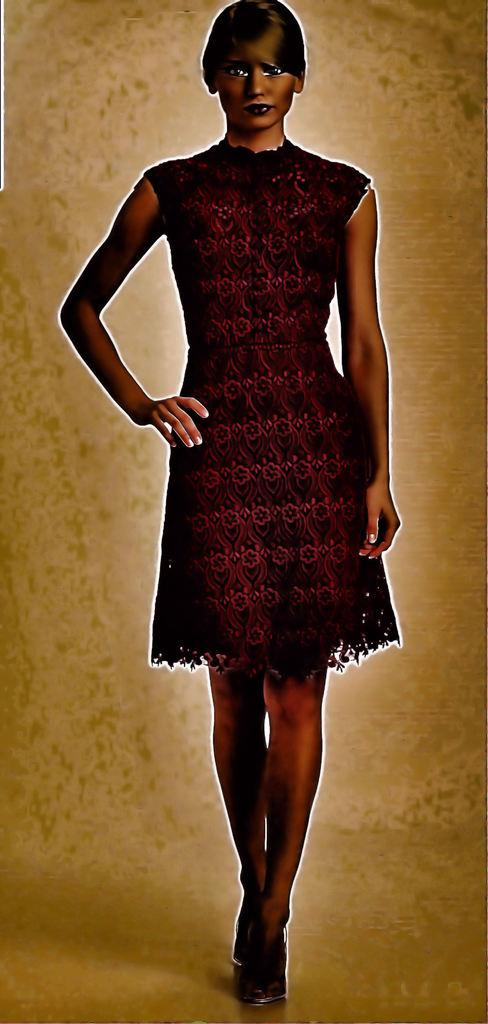Who is the main subject in the image? There is a woman in the image. What is the woman doing in the image? The woman is standing on the floor. What type of stone is the woman standing on in the image? There is no mention of a stone in the image; the woman is standing on the floor. 